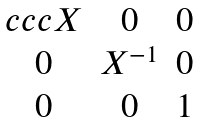<formula> <loc_0><loc_0><loc_500><loc_500>\begin{matrix} { c c c } X & 0 & 0 \\ 0 & X ^ { - 1 } & 0 \\ 0 & 0 & 1 \end{matrix}</formula> 